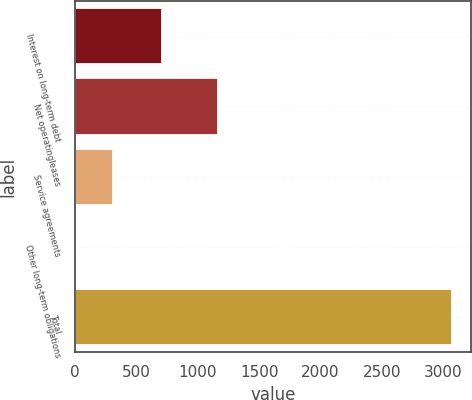Convert chart to OTSL. <chart><loc_0><loc_0><loc_500><loc_500><bar_chart><fcel>Interest on long-term debt<fcel>Net operatingleases<fcel>Service agreements<fcel>Other long-term obligations<fcel>Total<nl><fcel>710<fcel>1165<fcel>308.1<fcel>1<fcel>3072<nl></chart> 